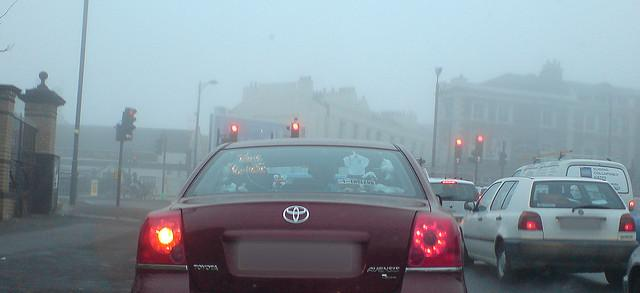Why are the license plates invisible?

Choices:
A) blurred
B) on front
C) new cars
D) stolen blurred 